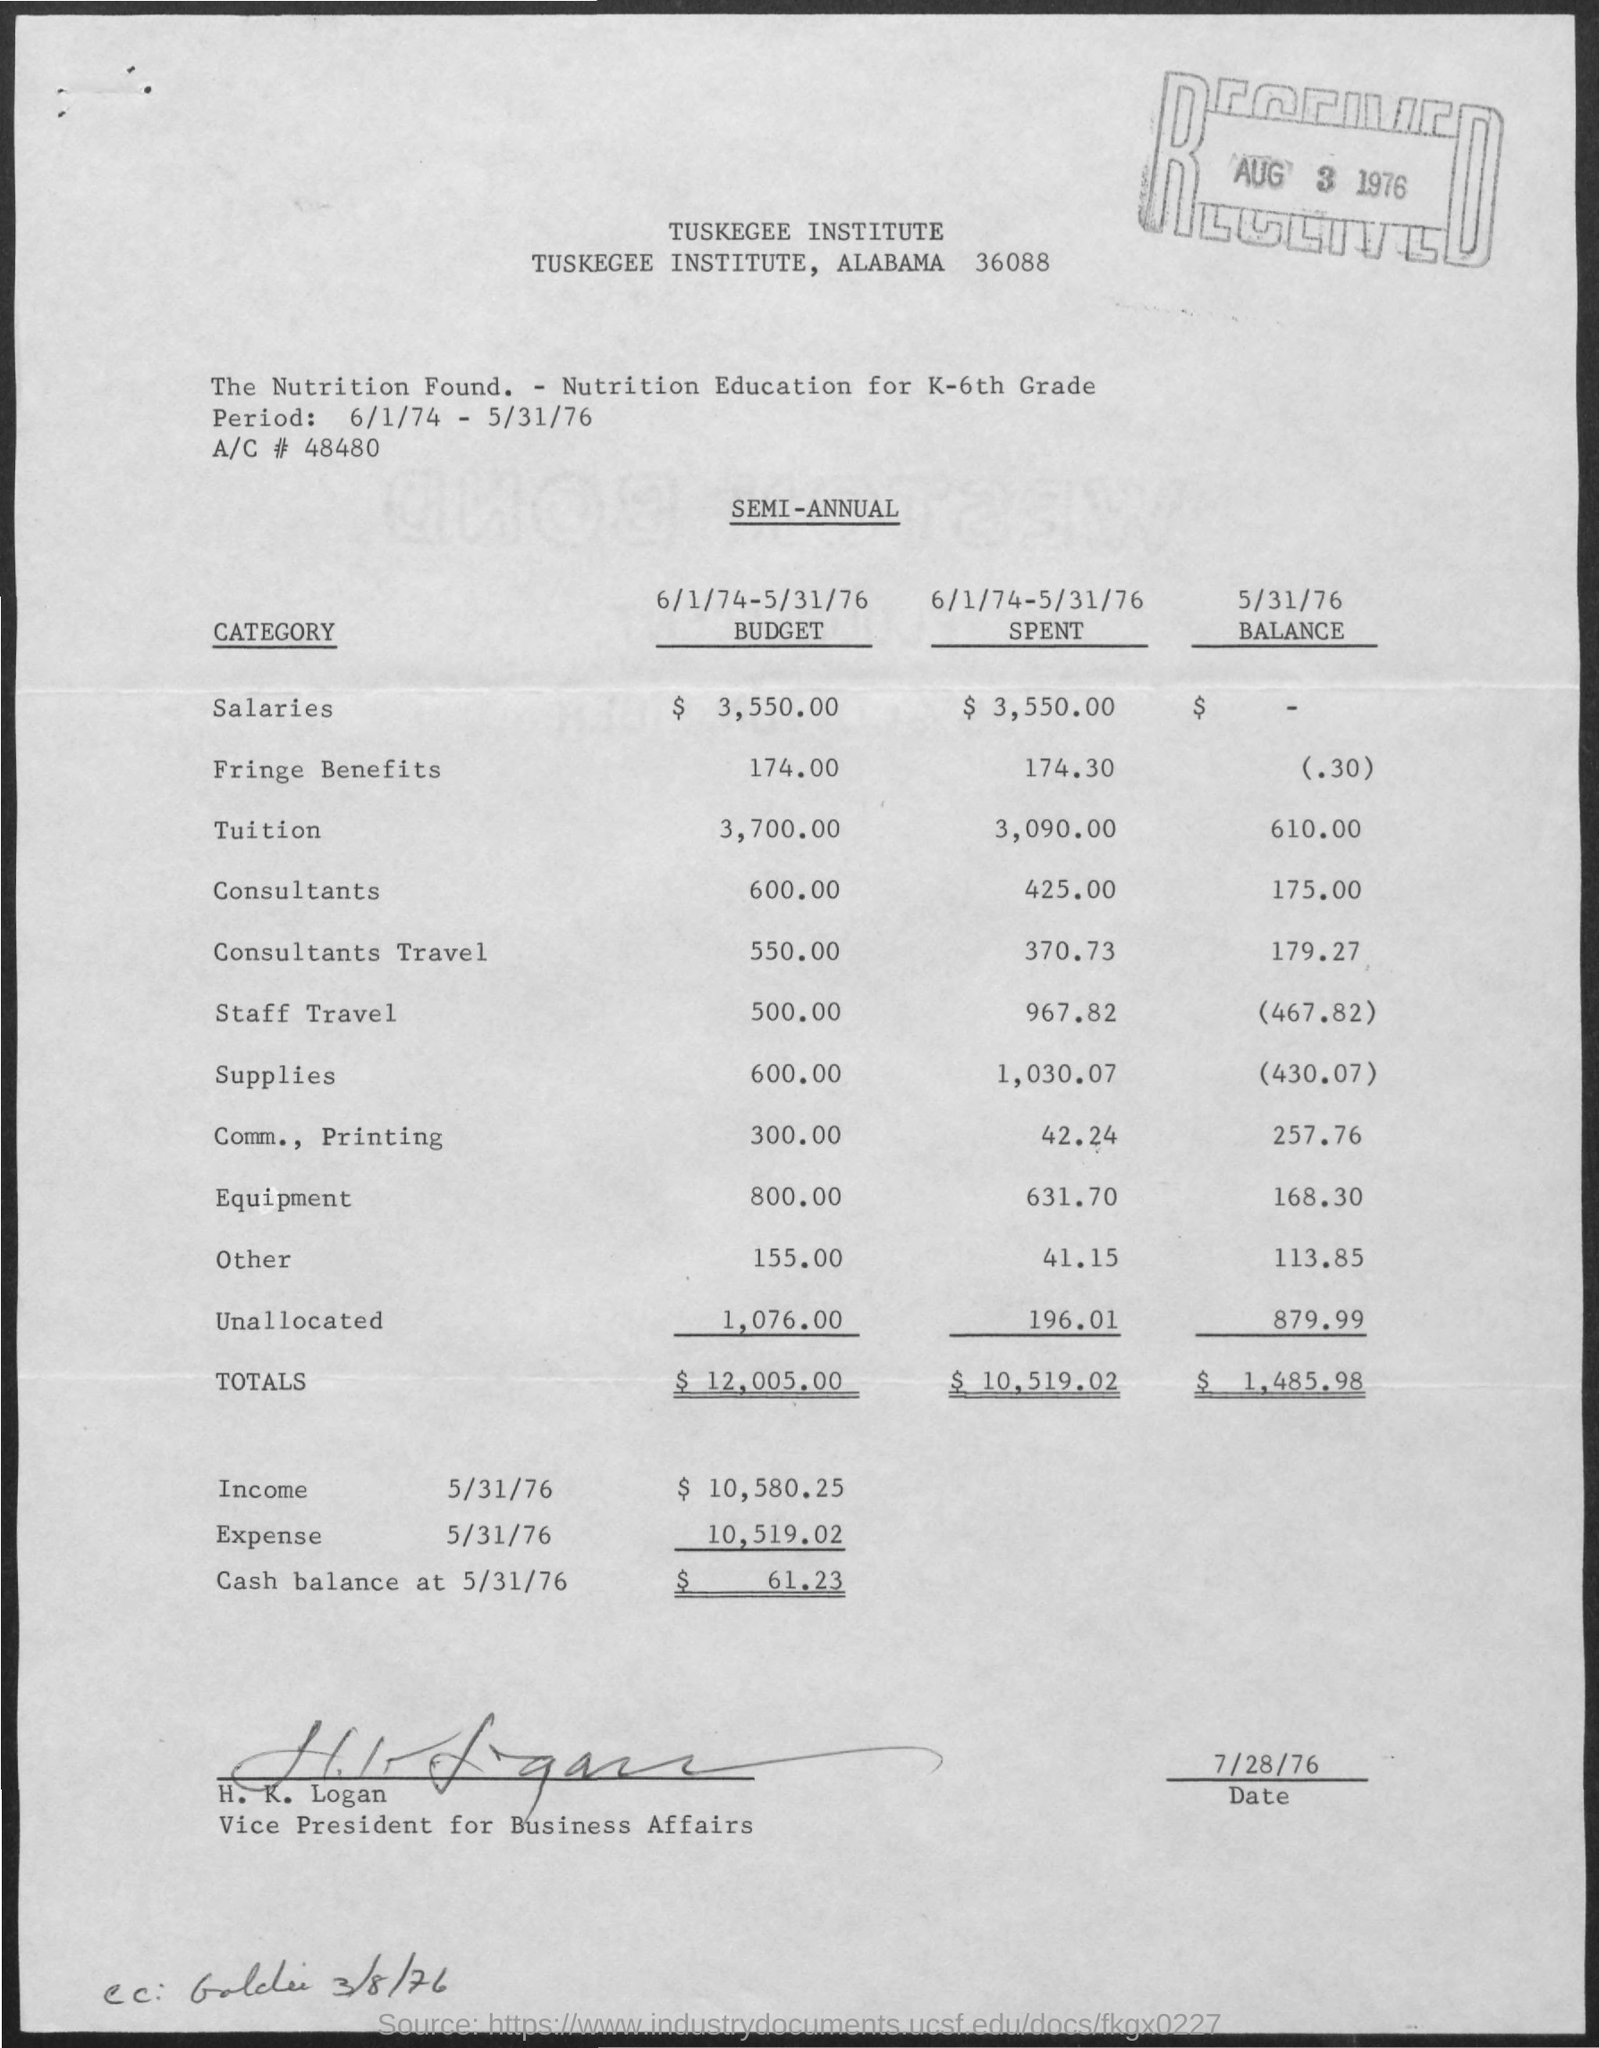What is cash balance at 5/31/76?
Your response must be concise. $61.23. Who signed the document?
Offer a very short reply. H. K Logan. What is the "period"?
Provide a succinct answer. 6/1/74 - 5/31/76. What is budget of "Fringe Benefits"?
Make the answer very short. 174.00. What is balance amount in "consultants"?
Keep it short and to the point. 175.00. 